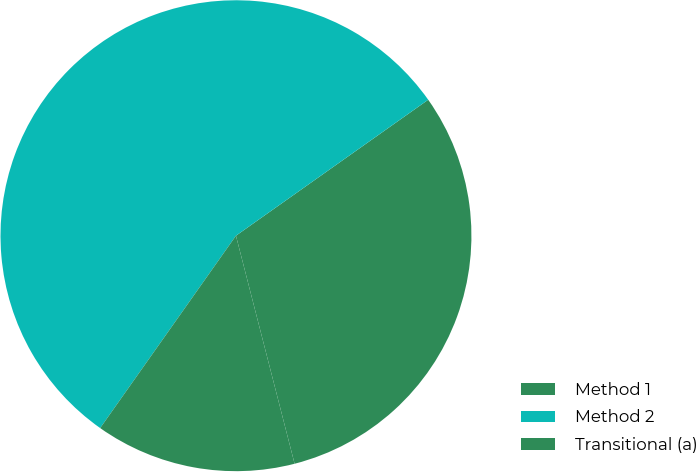<chart> <loc_0><loc_0><loc_500><loc_500><pie_chart><fcel>Method 1<fcel>Method 2<fcel>Transitional (a)<nl><fcel>30.79%<fcel>55.42%<fcel>13.79%<nl></chart> 